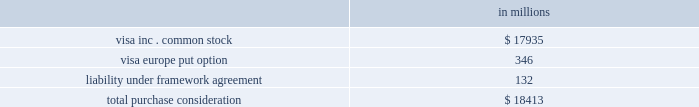Visa inc .
Notes to consolidated financial statements 2014 ( continued ) september 30 , 2009 ( in millions , except as noted ) note 2 2014the reorganization description of the reorganization and purchase consideration in a series of transactions from october 1 to october 3 , 2007 , visa undertook a reorganization in which visa u.s.a. , visa international , visa canada and inovant became direct or indirect subsidiaries of visa inc .
And the retrospective responsibility plan was established .
See note 4 2014retrospective responsibility plan .
For accounting purposes , the company reflected the reorganization as a single transaction occurring on october 1 ( the 201creorganization date 201d ) , using the purchase method of accounting with visa u.s.a .
As the accounting acquirer .
The net assets underlying the acquired interests in visa international , visa canada , and inovant ( the 201cacquired interests 201d ) were recorded at fair value at the reorganization date with the excess purchase price over this value attributed to goodwill .
Visa europe did not become a subsidiary of visa inc. , but rather remained owned and governed by its european member financial institutions and entered into a set of contractual arrangements with the company in connection with the reorganization .
The company issued different classes and series of common stock in the reorganization reflecting the different rights and obligations of the visa financial institution members and visa europe .
The allocation of the company 2019s common stock to each of visa ap , visa lac , visa cemea , visa canada ( collectively the 201cacquired regions 201d ) and visa u.s.a .
( collectively 201cthe participating regions 201d ) was based on each entity 2019s expected relative contribution to the company 2019s projected fiscal 2008 net income , after giving effect to negotiated adjustments .
This allocation was adjusted shortly prior to the ipo ( the 201ctrue- up 201d ) to reflect actual performance in the four quarters ended december 31 , 2007 .
The allocation of the company 2019s common stock and other consideration conveyed to visa europe in exchange for its ownership interest in visa international and inovant was determined based on the fair value of each element exchanged in the reorganization as discussed below and in note 3 2014visa europe .
Total shares authorized and issued to the financial institution member groups of the participating regions and to visa europe in the reorganization totaled 775080512 shares of class b and class c common stock .
Total purchase consideration , inclusive of the true-up , of approximately $ 18.4 billion comprised of the following: .
Visa inc .
Common stock issued in exchange for the acquired interests the value of the purchase consideration conveyed to each of the member groups of the acquired regions was determined by valuing the underlying businesses contributed by each , after giving effect to negotiated adjustments .
The fair value of the purchase consideration , consisting of 258022779 shares of class c ( series i ) common stock , was approximately $ 12.6 billion , measured at june 15 , 2007 , or the date on which all parties entered into the global restructuring agreement .
Additional purchase consideration of $ 1.2 billion , consisting of 26138056 incremental shares of class c common stock valued at $ 44 per share were issued to the acquired regions shortly before the ipo in connection with the true-up .
The fair value of these shares was determined based on the price per share in the ipo. .
Of the total purchase consideration , what portion is allocated for visa inc . common stock? 
Computations: (17935 / 18413)
Answer: 0.97404. 